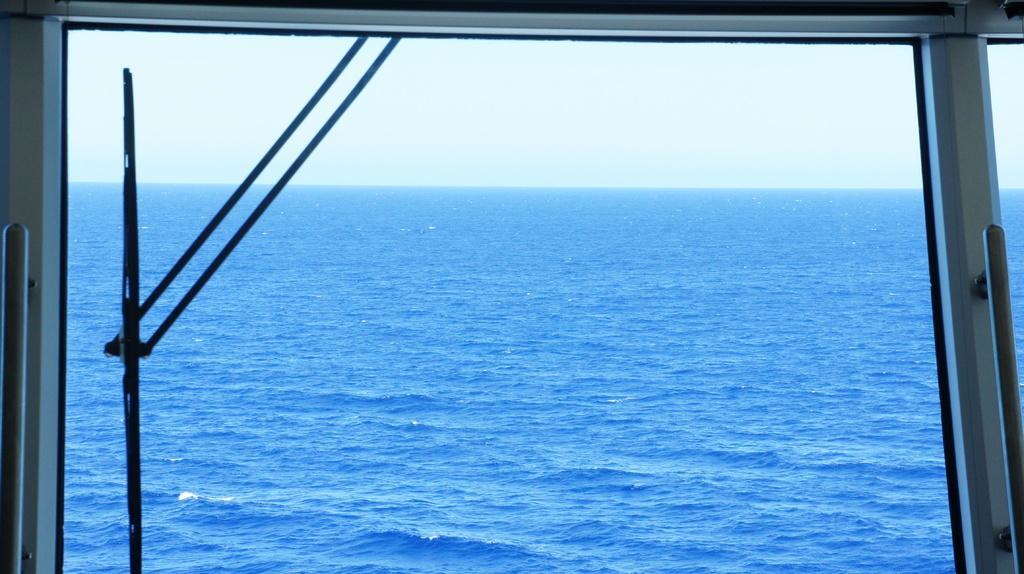In one or two sentences, can you explain what this image depicts? In this picture we can see a glass in the front, from the glass we can see water, on the left side there is a wiper, we can see the sky in the background. 